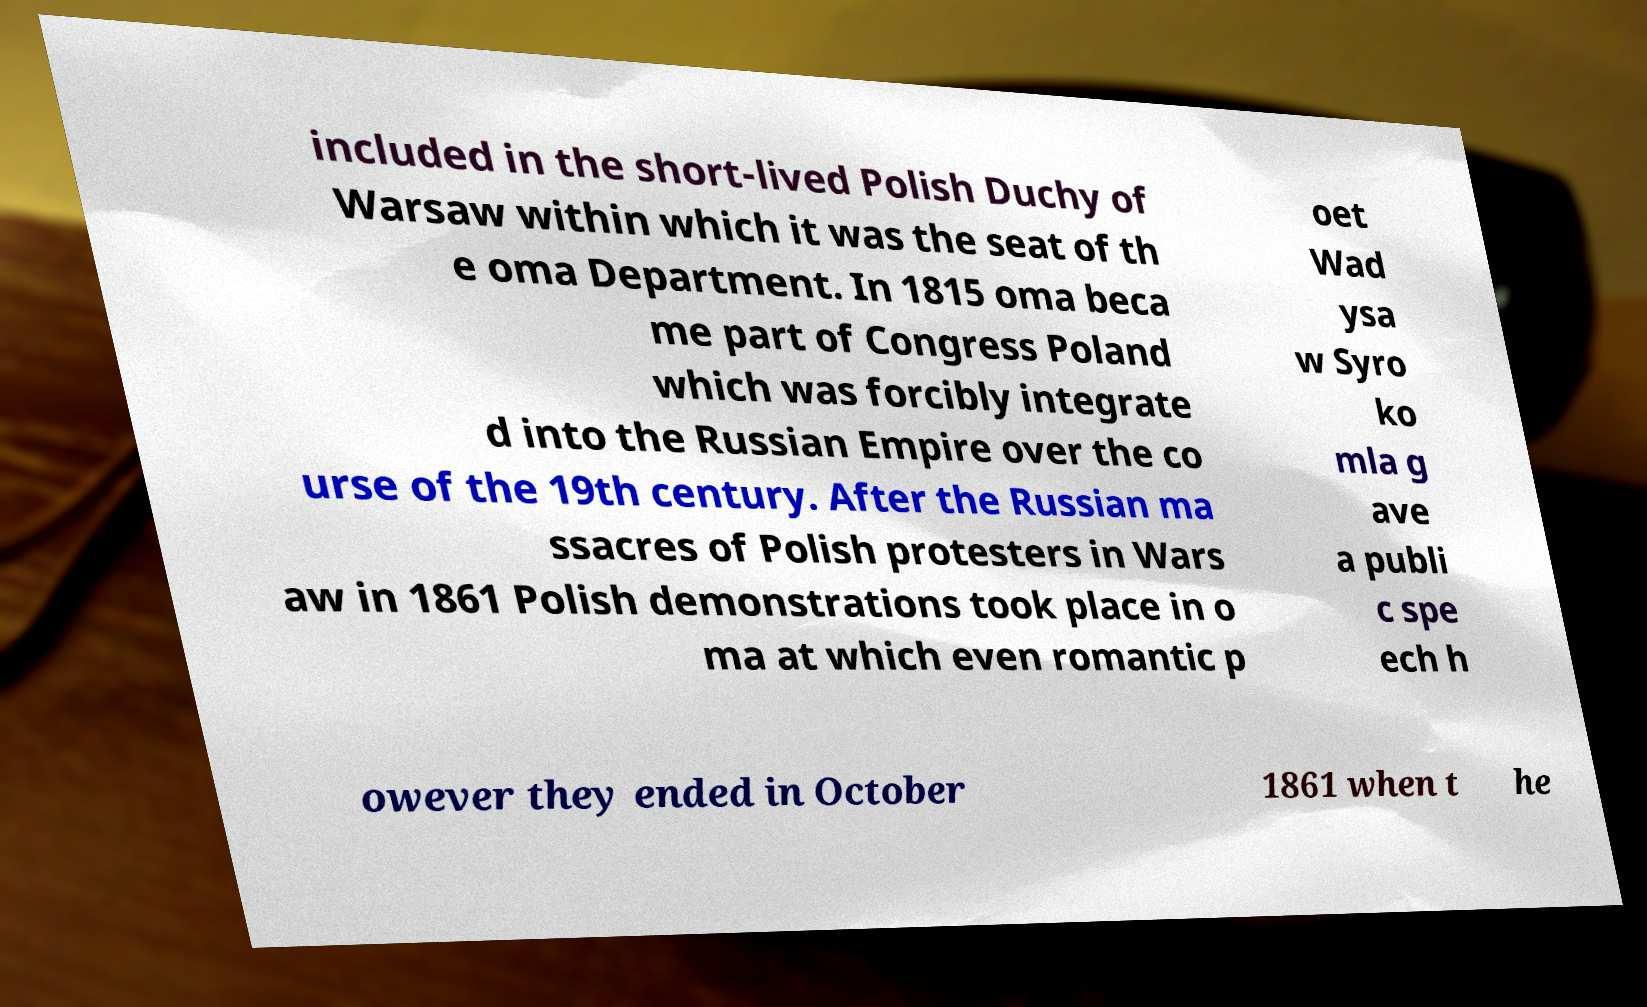Please identify and transcribe the text found in this image. included in the short-lived Polish Duchy of Warsaw within which it was the seat of th e oma Department. In 1815 oma beca me part of Congress Poland which was forcibly integrate d into the Russian Empire over the co urse of the 19th century. After the Russian ma ssacres of Polish protesters in Wars aw in 1861 Polish demonstrations took place in o ma at which even romantic p oet Wad ysa w Syro ko mla g ave a publi c spe ech h owever they ended in October 1861 when t he 